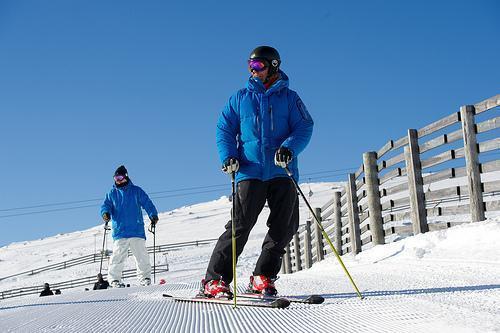How many people are in blue coats?
Give a very brief answer. 2. 